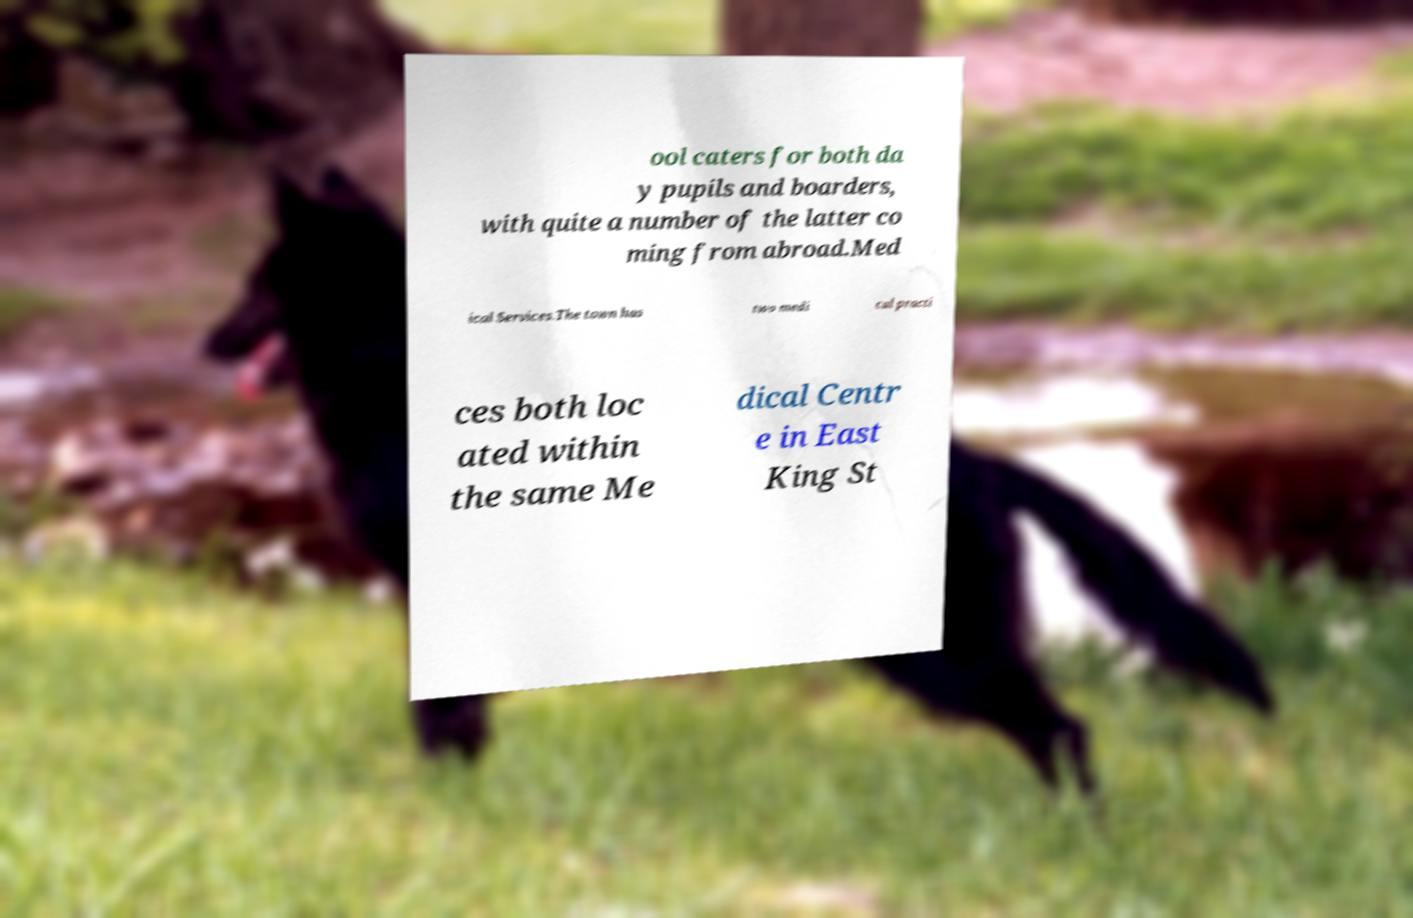I need the written content from this picture converted into text. Can you do that? ool caters for both da y pupils and boarders, with quite a number of the latter co ming from abroad.Med ical Services.The town has two medi cal practi ces both loc ated within the same Me dical Centr e in East King St 